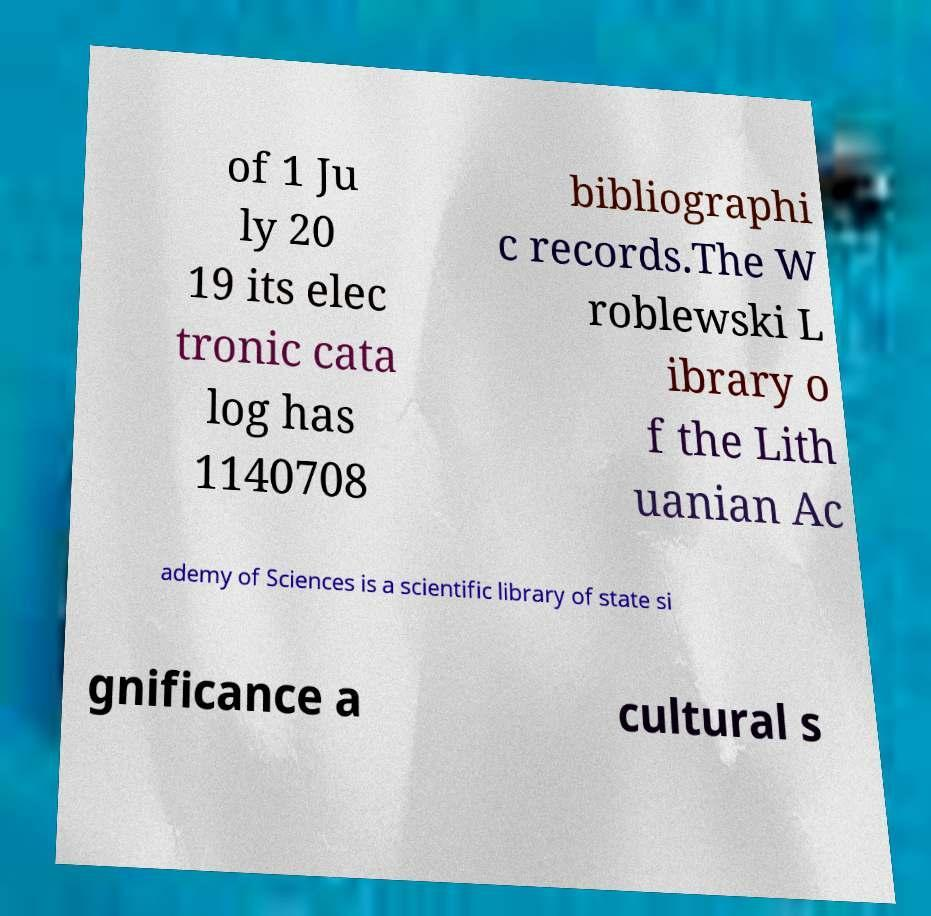What messages or text are displayed in this image? I need them in a readable, typed format. of 1 Ju ly 20 19 its elec tronic cata log has 1140708 bibliographi c records.The W roblewski L ibrary o f the Lith uanian Ac ademy of Sciences is a scientific library of state si gnificance a cultural s 